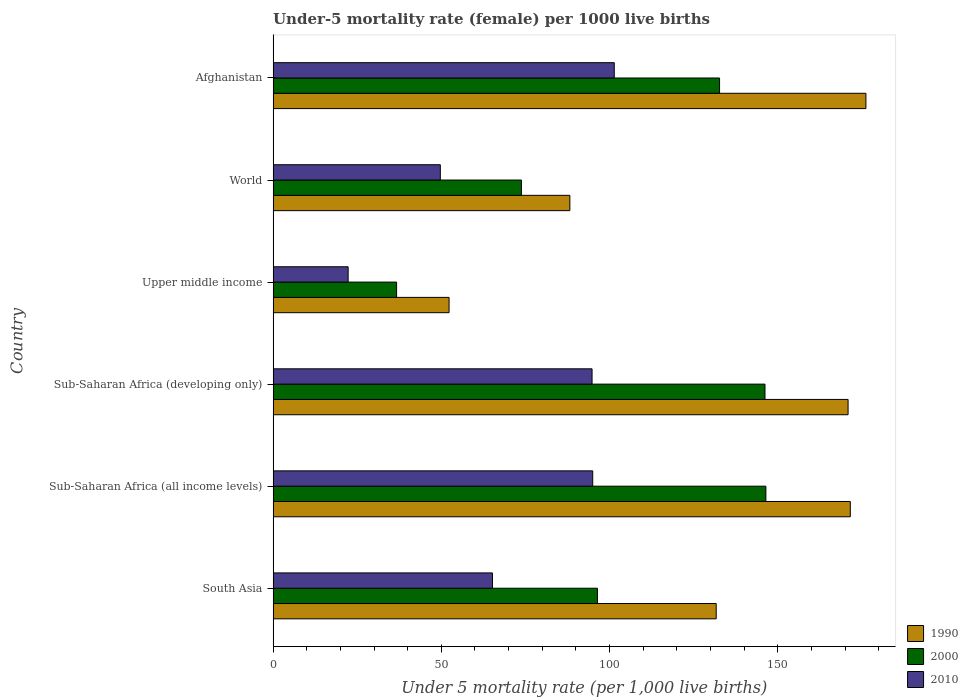Are the number of bars per tick equal to the number of legend labels?
Provide a short and direct response. Yes. How many bars are there on the 1st tick from the top?
Ensure brevity in your answer.  3. How many bars are there on the 2nd tick from the bottom?
Your response must be concise. 3. In how many cases, is the number of bars for a given country not equal to the number of legend labels?
Provide a short and direct response. 0. What is the under-five mortality rate in 1990 in South Asia?
Ensure brevity in your answer.  131.7. Across all countries, what is the maximum under-five mortality rate in 1990?
Make the answer very short. 176.2. Across all countries, what is the minimum under-five mortality rate in 2000?
Your answer should be very brief. 36.7. In which country was the under-five mortality rate in 2000 maximum?
Keep it short and to the point. Sub-Saharan Africa (all income levels). In which country was the under-five mortality rate in 1990 minimum?
Provide a short and direct response. Upper middle income. What is the total under-five mortality rate in 1990 in the graph?
Keep it short and to the point. 790.86. What is the difference between the under-five mortality rate in 1990 in Afghanistan and that in Upper middle income?
Offer a terse response. 123.9. What is the average under-five mortality rate in 2010 per country?
Your response must be concise. 71.4. What is the difference between the under-five mortality rate in 1990 and under-five mortality rate in 2000 in Sub-Saharan Africa (developing only)?
Your answer should be very brief. 24.7. In how many countries, is the under-five mortality rate in 1990 greater than 130 ?
Make the answer very short. 4. What is the ratio of the under-five mortality rate in 2010 in Afghanistan to that in Sub-Saharan Africa (all income levels)?
Provide a succinct answer. 1.07. What is the difference between the highest and the second highest under-five mortality rate in 1990?
Give a very brief answer. 4.64. What is the difference between the highest and the lowest under-five mortality rate in 1990?
Your answer should be compact. 123.9. In how many countries, is the under-five mortality rate in 2010 greater than the average under-five mortality rate in 2010 taken over all countries?
Your answer should be compact. 3. Is the sum of the under-five mortality rate in 1990 in Afghanistan and South Asia greater than the maximum under-five mortality rate in 2010 across all countries?
Provide a succinct answer. Yes. What does the 1st bar from the top in Sub-Saharan Africa (all income levels) represents?
Your answer should be compact. 2010. What does the 1st bar from the bottom in Afghanistan represents?
Your answer should be very brief. 1990. Is it the case that in every country, the sum of the under-five mortality rate in 1990 and under-five mortality rate in 2000 is greater than the under-five mortality rate in 2010?
Offer a very short reply. Yes. How many bars are there?
Keep it short and to the point. 18. How many countries are there in the graph?
Offer a very short reply. 6. What is the difference between two consecutive major ticks on the X-axis?
Make the answer very short. 50. Are the values on the major ticks of X-axis written in scientific E-notation?
Provide a short and direct response. No. Does the graph contain any zero values?
Offer a terse response. No. How are the legend labels stacked?
Your answer should be very brief. Vertical. What is the title of the graph?
Your answer should be very brief. Under-5 mortality rate (female) per 1000 live births. Does "1972" appear as one of the legend labels in the graph?
Provide a succinct answer. No. What is the label or title of the X-axis?
Offer a very short reply. Under 5 mortality rate (per 1,0 live births). What is the label or title of the Y-axis?
Offer a terse response. Country. What is the Under 5 mortality rate (per 1,000 live births) in 1990 in South Asia?
Your answer should be compact. 131.7. What is the Under 5 mortality rate (per 1,000 live births) in 2000 in South Asia?
Offer a terse response. 96.4. What is the Under 5 mortality rate (per 1,000 live births) in 2010 in South Asia?
Your response must be concise. 65.2. What is the Under 5 mortality rate (per 1,000 live births) in 1990 in Sub-Saharan Africa (all income levels)?
Ensure brevity in your answer.  171.56. What is the Under 5 mortality rate (per 1,000 live births) in 2000 in Sub-Saharan Africa (all income levels)?
Give a very brief answer. 146.47. What is the Under 5 mortality rate (per 1,000 live births) in 2010 in Sub-Saharan Africa (all income levels)?
Offer a very short reply. 95. What is the Under 5 mortality rate (per 1,000 live births) in 1990 in Sub-Saharan Africa (developing only)?
Your response must be concise. 170.9. What is the Under 5 mortality rate (per 1,000 live births) of 2000 in Sub-Saharan Africa (developing only)?
Your answer should be very brief. 146.2. What is the Under 5 mortality rate (per 1,000 live births) of 2010 in Sub-Saharan Africa (developing only)?
Ensure brevity in your answer.  94.8. What is the Under 5 mortality rate (per 1,000 live births) of 1990 in Upper middle income?
Provide a short and direct response. 52.3. What is the Under 5 mortality rate (per 1,000 live births) in 2000 in Upper middle income?
Make the answer very short. 36.7. What is the Under 5 mortality rate (per 1,000 live births) of 2010 in Upper middle income?
Provide a succinct answer. 22.3. What is the Under 5 mortality rate (per 1,000 live births) of 1990 in World?
Provide a succinct answer. 88.2. What is the Under 5 mortality rate (per 1,000 live births) of 2000 in World?
Give a very brief answer. 73.8. What is the Under 5 mortality rate (per 1,000 live births) in 2010 in World?
Provide a short and direct response. 49.7. What is the Under 5 mortality rate (per 1,000 live births) of 1990 in Afghanistan?
Make the answer very short. 176.2. What is the Under 5 mortality rate (per 1,000 live births) of 2000 in Afghanistan?
Make the answer very short. 132.7. What is the Under 5 mortality rate (per 1,000 live births) of 2010 in Afghanistan?
Your response must be concise. 101.4. Across all countries, what is the maximum Under 5 mortality rate (per 1,000 live births) of 1990?
Your answer should be very brief. 176.2. Across all countries, what is the maximum Under 5 mortality rate (per 1,000 live births) in 2000?
Ensure brevity in your answer.  146.47. Across all countries, what is the maximum Under 5 mortality rate (per 1,000 live births) of 2010?
Provide a succinct answer. 101.4. Across all countries, what is the minimum Under 5 mortality rate (per 1,000 live births) of 1990?
Your response must be concise. 52.3. Across all countries, what is the minimum Under 5 mortality rate (per 1,000 live births) of 2000?
Ensure brevity in your answer.  36.7. Across all countries, what is the minimum Under 5 mortality rate (per 1,000 live births) of 2010?
Keep it short and to the point. 22.3. What is the total Under 5 mortality rate (per 1,000 live births) in 1990 in the graph?
Give a very brief answer. 790.86. What is the total Under 5 mortality rate (per 1,000 live births) in 2000 in the graph?
Offer a very short reply. 632.26. What is the total Under 5 mortality rate (per 1,000 live births) of 2010 in the graph?
Provide a succinct answer. 428.4. What is the difference between the Under 5 mortality rate (per 1,000 live births) of 1990 in South Asia and that in Sub-Saharan Africa (all income levels)?
Your answer should be compact. -39.86. What is the difference between the Under 5 mortality rate (per 1,000 live births) of 2000 in South Asia and that in Sub-Saharan Africa (all income levels)?
Give a very brief answer. -50.06. What is the difference between the Under 5 mortality rate (per 1,000 live births) in 2010 in South Asia and that in Sub-Saharan Africa (all income levels)?
Make the answer very short. -29.8. What is the difference between the Under 5 mortality rate (per 1,000 live births) of 1990 in South Asia and that in Sub-Saharan Africa (developing only)?
Your answer should be compact. -39.2. What is the difference between the Under 5 mortality rate (per 1,000 live births) of 2000 in South Asia and that in Sub-Saharan Africa (developing only)?
Provide a succinct answer. -49.8. What is the difference between the Under 5 mortality rate (per 1,000 live births) of 2010 in South Asia and that in Sub-Saharan Africa (developing only)?
Your response must be concise. -29.6. What is the difference between the Under 5 mortality rate (per 1,000 live births) of 1990 in South Asia and that in Upper middle income?
Your response must be concise. 79.4. What is the difference between the Under 5 mortality rate (per 1,000 live births) of 2000 in South Asia and that in Upper middle income?
Offer a terse response. 59.7. What is the difference between the Under 5 mortality rate (per 1,000 live births) in 2010 in South Asia and that in Upper middle income?
Ensure brevity in your answer.  42.9. What is the difference between the Under 5 mortality rate (per 1,000 live births) of 1990 in South Asia and that in World?
Provide a succinct answer. 43.5. What is the difference between the Under 5 mortality rate (per 1,000 live births) of 2000 in South Asia and that in World?
Your answer should be compact. 22.6. What is the difference between the Under 5 mortality rate (per 1,000 live births) of 1990 in South Asia and that in Afghanistan?
Your answer should be very brief. -44.5. What is the difference between the Under 5 mortality rate (per 1,000 live births) in 2000 in South Asia and that in Afghanistan?
Provide a succinct answer. -36.3. What is the difference between the Under 5 mortality rate (per 1,000 live births) in 2010 in South Asia and that in Afghanistan?
Provide a short and direct response. -36.2. What is the difference between the Under 5 mortality rate (per 1,000 live births) of 1990 in Sub-Saharan Africa (all income levels) and that in Sub-Saharan Africa (developing only)?
Make the answer very short. 0.66. What is the difference between the Under 5 mortality rate (per 1,000 live births) in 2000 in Sub-Saharan Africa (all income levels) and that in Sub-Saharan Africa (developing only)?
Make the answer very short. 0.27. What is the difference between the Under 5 mortality rate (per 1,000 live births) in 2010 in Sub-Saharan Africa (all income levels) and that in Sub-Saharan Africa (developing only)?
Offer a terse response. 0.2. What is the difference between the Under 5 mortality rate (per 1,000 live births) in 1990 in Sub-Saharan Africa (all income levels) and that in Upper middle income?
Provide a succinct answer. 119.26. What is the difference between the Under 5 mortality rate (per 1,000 live births) in 2000 in Sub-Saharan Africa (all income levels) and that in Upper middle income?
Provide a short and direct response. 109.77. What is the difference between the Under 5 mortality rate (per 1,000 live births) of 2010 in Sub-Saharan Africa (all income levels) and that in Upper middle income?
Your answer should be compact. 72.7. What is the difference between the Under 5 mortality rate (per 1,000 live births) of 1990 in Sub-Saharan Africa (all income levels) and that in World?
Your answer should be compact. 83.36. What is the difference between the Under 5 mortality rate (per 1,000 live births) of 2000 in Sub-Saharan Africa (all income levels) and that in World?
Provide a succinct answer. 72.67. What is the difference between the Under 5 mortality rate (per 1,000 live births) of 2010 in Sub-Saharan Africa (all income levels) and that in World?
Provide a succinct answer. 45.3. What is the difference between the Under 5 mortality rate (per 1,000 live births) of 1990 in Sub-Saharan Africa (all income levels) and that in Afghanistan?
Offer a terse response. -4.64. What is the difference between the Under 5 mortality rate (per 1,000 live births) in 2000 in Sub-Saharan Africa (all income levels) and that in Afghanistan?
Ensure brevity in your answer.  13.77. What is the difference between the Under 5 mortality rate (per 1,000 live births) in 2010 in Sub-Saharan Africa (all income levels) and that in Afghanistan?
Make the answer very short. -6.4. What is the difference between the Under 5 mortality rate (per 1,000 live births) in 1990 in Sub-Saharan Africa (developing only) and that in Upper middle income?
Your answer should be compact. 118.6. What is the difference between the Under 5 mortality rate (per 1,000 live births) in 2000 in Sub-Saharan Africa (developing only) and that in Upper middle income?
Offer a terse response. 109.5. What is the difference between the Under 5 mortality rate (per 1,000 live births) of 2010 in Sub-Saharan Africa (developing only) and that in Upper middle income?
Your response must be concise. 72.5. What is the difference between the Under 5 mortality rate (per 1,000 live births) of 1990 in Sub-Saharan Africa (developing only) and that in World?
Your answer should be very brief. 82.7. What is the difference between the Under 5 mortality rate (per 1,000 live births) in 2000 in Sub-Saharan Africa (developing only) and that in World?
Give a very brief answer. 72.4. What is the difference between the Under 5 mortality rate (per 1,000 live births) in 2010 in Sub-Saharan Africa (developing only) and that in World?
Your response must be concise. 45.1. What is the difference between the Under 5 mortality rate (per 1,000 live births) in 1990 in Sub-Saharan Africa (developing only) and that in Afghanistan?
Make the answer very short. -5.3. What is the difference between the Under 5 mortality rate (per 1,000 live births) in 2010 in Sub-Saharan Africa (developing only) and that in Afghanistan?
Make the answer very short. -6.6. What is the difference between the Under 5 mortality rate (per 1,000 live births) in 1990 in Upper middle income and that in World?
Provide a succinct answer. -35.9. What is the difference between the Under 5 mortality rate (per 1,000 live births) of 2000 in Upper middle income and that in World?
Ensure brevity in your answer.  -37.1. What is the difference between the Under 5 mortality rate (per 1,000 live births) in 2010 in Upper middle income and that in World?
Ensure brevity in your answer.  -27.4. What is the difference between the Under 5 mortality rate (per 1,000 live births) in 1990 in Upper middle income and that in Afghanistan?
Keep it short and to the point. -123.9. What is the difference between the Under 5 mortality rate (per 1,000 live births) in 2000 in Upper middle income and that in Afghanistan?
Keep it short and to the point. -96. What is the difference between the Under 5 mortality rate (per 1,000 live births) of 2010 in Upper middle income and that in Afghanistan?
Ensure brevity in your answer.  -79.1. What is the difference between the Under 5 mortality rate (per 1,000 live births) in 1990 in World and that in Afghanistan?
Your answer should be compact. -88. What is the difference between the Under 5 mortality rate (per 1,000 live births) in 2000 in World and that in Afghanistan?
Provide a short and direct response. -58.9. What is the difference between the Under 5 mortality rate (per 1,000 live births) in 2010 in World and that in Afghanistan?
Your answer should be very brief. -51.7. What is the difference between the Under 5 mortality rate (per 1,000 live births) in 1990 in South Asia and the Under 5 mortality rate (per 1,000 live births) in 2000 in Sub-Saharan Africa (all income levels)?
Keep it short and to the point. -14.77. What is the difference between the Under 5 mortality rate (per 1,000 live births) in 1990 in South Asia and the Under 5 mortality rate (per 1,000 live births) in 2010 in Sub-Saharan Africa (all income levels)?
Offer a terse response. 36.7. What is the difference between the Under 5 mortality rate (per 1,000 live births) of 2000 in South Asia and the Under 5 mortality rate (per 1,000 live births) of 2010 in Sub-Saharan Africa (all income levels)?
Your response must be concise. 1.4. What is the difference between the Under 5 mortality rate (per 1,000 live births) in 1990 in South Asia and the Under 5 mortality rate (per 1,000 live births) in 2010 in Sub-Saharan Africa (developing only)?
Offer a very short reply. 36.9. What is the difference between the Under 5 mortality rate (per 1,000 live births) in 2000 in South Asia and the Under 5 mortality rate (per 1,000 live births) in 2010 in Sub-Saharan Africa (developing only)?
Offer a very short reply. 1.6. What is the difference between the Under 5 mortality rate (per 1,000 live births) in 1990 in South Asia and the Under 5 mortality rate (per 1,000 live births) in 2000 in Upper middle income?
Offer a very short reply. 95. What is the difference between the Under 5 mortality rate (per 1,000 live births) in 1990 in South Asia and the Under 5 mortality rate (per 1,000 live births) in 2010 in Upper middle income?
Offer a very short reply. 109.4. What is the difference between the Under 5 mortality rate (per 1,000 live births) in 2000 in South Asia and the Under 5 mortality rate (per 1,000 live births) in 2010 in Upper middle income?
Make the answer very short. 74.1. What is the difference between the Under 5 mortality rate (per 1,000 live births) of 1990 in South Asia and the Under 5 mortality rate (per 1,000 live births) of 2000 in World?
Provide a succinct answer. 57.9. What is the difference between the Under 5 mortality rate (per 1,000 live births) in 1990 in South Asia and the Under 5 mortality rate (per 1,000 live births) in 2010 in World?
Your answer should be compact. 82. What is the difference between the Under 5 mortality rate (per 1,000 live births) in 2000 in South Asia and the Under 5 mortality rate (per 1,000 live births) in 2010 in World?
Your response must be concise. 46.7. What is the difference between the Under 5 mortality rate (per 1,000 live births) in 1990 in South Asia and the Under 5 mortality rate (per 1,000 live births) in 2010 in Afghanistan?
Provide a succinct answer. 30.3. What is the difference between the Under 5 mortality rate (per 1,000 live births) in 1990 in Sub-Saharan Africa (all income levels) and the Under 5 mortality rate (per 1,000 live births) in 2000 in Sub-Saharan Africa (developing only)?
Provide a short and direct response. 25.36. What is the difference between the Under 5 mortality rate (per 1,000 live births) of 1990 in Sub-Saharan Africa (all income levels) and the Under 5 mortality rate (per 1,000 live births) of 2010 in Sub-Saharan Africa (developing only)?
Offer a very short reply. 76.76. What is the difference between the Under 5 mortality rate (per 1,000 live births) in 2000 in Sub-Saharan Africa (all income levels) and the Under 5 mortality rate (per 1,000 live births) in 2010 in Sub-Saharan Africa (developing only)?
Offer a terse response. 51.66. What is the difference between the Under 5 mortality rate (per 1,000 live births) in 1990 in Sub-Saharan Africa (all income levels) and the Under 5 mortality rate (per 1,000 live births) in 2000 in Upper middle income?
Give a very brief answer. 134.86. What is the difference between the Under 5 mortality rate (per 1,000 live births) in 1990 in Sub-Saharan Africa (all income levels) and the Under 5 mortality rate (per 1,000 live births) in 2010 in Upper middle income?
Ensure brevity in your answer.  149.26. What is the difference between the Under 5 mortality rate (per 1,000 live births) in 2000 in Sub-Saharan Africa (all income levels) and the Under 5 mortality rate (per 1,000 live births) in 2010 in Upper middle income?
Offer a terse response. 124.17. What is the difference between the Under 5 mortality rate (per 1,000 live births) in 1990 in Sub-Saharan Africa (all income levels) and the Under 5 mortality rate (per 1,000 live births) in 2000 in World?
Offer a terse response. 97.76. What is the difference between the Under 5 mortality rate (per 1,000 live births) in 1990 in Sub-Saharan Africa (all income levels) and the Under 5 mortality rate (per 1,000 live births) in 2010 in World?
Offer a very short reply. 121.86. What is the difference between the Under 5 mortality rate (per 1,000 live births) in 2000 in Sub-Saharan Africa (all income levels) and the Under 5 mortality rate (per 1,000 live births) in 2010 in World?
Keep it short and to the point. 96.77. What is the difference between the Under 5 mortality rate (per 1,000 live births) in 1990 in Sub-Saharan Africa (all income levels) and the Under 5 mortality rate (per 1,000 live births) in 2000 in Afghanistan?
Make the answer very short. 38.86. What is the difference between the Under 5 mortality rate (per 1,000 live births) of 1990 in Sub-Saharan Africa (all income levels) and the Under 5 mortality rate (per 1,000 live births) of 2010 in Afghanistan?
Offer a very short reply. 70.16. What is the difference between the Under 5 mortality rate (per 1,000 live births) in 2000 in Sub-Saharan Africa (all income levels) and the Under 5 mortality rate (per 1,000 live births) in 2010 in Afghanistan?
Provide a short and direct response. 45.06. What is the difference between the Under 5 mortality rate (per 1,000 live births) of 1990 in Sub-Saharan Africa (developing only) and the Under 5 mortality rate (per 1,000 live births) of 2000 in Upper middle income?
Offer a very short reply. 134.2. What is the difference between the Under 5 mortality rate (per 1,000 live births) of 1990 in Sub-Saharan Africa (developing only) and the Under 5 mortality rate (per 1,000 live births) of 2010 in Upper middle income?
Ensure brevity in your answer.  148.6. What is the difference between the Under 5 mortality rate (per 1,000 live births) of 2000 in Sub-Saharan Africa (developing only) and the Under 5 mortality rate (per 1,000 live births) of 2010 in Upper middle income?
Your answer should be compact. 123.9. What is the difference between the Under 5 mortality rate (per 1,000 live births) of 1990 in Sub-Saharan Africa (developing only) and the Under 5 mortality rate (per 1,000 live births) of 2000 in World?
Offer a very short reply. 97.1. What is the difference between the Under 5 mortality rate (per 1,000 live births) of 1990 in Sub-Saharan Africa (developing only) and the Under 5 mortality rate (per 1,000 live births) of 2010 in World?
Provide a succinct answer. 121.2. What is the difference between the Under 5 mortality rate (per 1,000 live births) of 2000 in Sub-Saharan Africa (developing only) and the Under 5 mortality rate (per 1,000 live births) of 2010 in World?
Your answer should be very brief. 96.5. What is the difference between the Under 5 mortality rate (per 1,000 live births) in 1990 in Sub-Saharan Africa (developing only) and the Under 5 mortality rate (per 1,000 live births) in 2000 in Afghanistan?
Give a very brief answer. 38.2. What is the difference between the Under 5 mortality rate (per 1,000 live births) in 1990 in Sub-Saharan Africa (developing only) and the Under 5 mortality rate (per 1,000 live births) in 2010 in Afghanistan?
Give a very brief answer. 69.5. What is the difference between the Under 5 mortality rate (per 1,000 live births) in 2000 in Sub-Saharan Africa (developing only) and the Under 5 mortality rate (per 1,000 live births) in 2010 in Afghanistan?
Provide a short and direct response. 44.8. What is the difference between the Under 5 mortality rate (per 1,000 live births) in 1990 in Upper middle income and the Under 5 mortality rate (per 1,000 live births) in 2000 in World?
Give a very brief answer. -21.5. What is the difference between the Under 5 mortality rate (per 1,000 live births) in 2000 in Upper middle income and the Under 5 mortality rate (per 1,000 live births) in 2010 in World?
Give a very brief answer. -13. What is the difference between the Under 5 mortality rate (per 1,000 live births) of 1990 in Upper middle income and the Under 5 mortality rate (per 1,000 live births) of 2000 in Afghanistan?
Ensure brevity in your answer.  -80.4. What is the difference between the Under 5 mortality rate (per 1,000 live births) of 1990 in Upper middle income and the Under 5 mortality rate (per 1,000 live births) of 2010 in Afghanistan?
Your answer should be compact. -49.1. What is the difference between the Under 5 mortality rate (per 1,000 live births) in 2000 in Upper middle income and the Under 5 mortality rate (per 1,000 live births) in 2010 in Afghanistan?
Your answer should be very brief. -64.7. What is the difference between the Under 5 mortality rate (per 1,000 live births) in 1990 in World and the Under 5 mortality rate (per 1,000 live births) in 2000 in Afghanistan?
Offer a very short reply. -44.5. What is the difference between the Under 5 mortality rate (per 1,000 live births) of 1990 in World and the Under 5 mortality rate (per 1,000 live births) of 2010 in Afghanistan?
Your answer should be very brief. -13.2. What is the difference between the Under 5 mortality rate (per 1,000 live births) of 2000 in World and the Under 5 mortality rate (per 1,000 live births) of 2010 in Afghanistan?
Your response must be concise. -27.6. What is the average Under 5 mortality rate (per 1,000 live births) in 1990 per country?
Your answer should be compact. 131.81. What is the average Under 5 mortality rate (per 1,000 live births) of 2000 per country?
Provide a short and direct response. 105.38. What is the average Under 5 mortality rate (per 1,000 live births) of 2010 per country?
Give a very brief answer. 71.4. What is the difference between the Under 5 mortality rate (per 1,000 live births) of 1990 and Under 5 mortality rate (per 1,000 live births) of 2000 in South Asia?
Keep it short and to the point. 35.3. What is the difference between the Under 5 mortality rate (per 1,000 live births) in 1990 and Under 5 mortality rate (per 1,000 live births) in 2010 in South Asia?
Keep it short and to the point. 66.5. What is the difference between the Under 5 mortality rate (per 1,000 live births) in 2000 and Under 5 mortality rate (per 1,000 live births) in 2010 in South Asia?
Offer a very short reply. 31.2. What is the difference between the Under 5 mortality rate (per 1,000 live births) of 1990 and Under 5 mortality rate (per 1,000 live births) of 2000 in Sub-Saharan Africa (all income levels)?
Give a very brief answer. 25.09. What is the difference between the Under 5 mortality rate (per 1,000 live births) in 1990 and Under 5 mortality rate (per 1,000 live births) in 2010 in Sub-Saharan Africa (all income levels)?
Provide a short and direct response. 76.56. What is the difference between the Under 5 mortality rate (per 1,000 live births) of 2000 and Under 5 mortality rate (per 1,000 live births) of 2010 in Sub-Saharan Africa (all income levels)?
Keep it short and to the point. 51.47. What is the difference between the Under 5 mortality rate (per 1,000 live births) in 1990 and Under 5 mortality rate (per 1,000 live births) in 2000 in Sub-Saharan Africa (developing only)?
Offer a terse response. 24.7. What is the difference between the Under 5 mortality rate (per 1,000 live births) in 1990 and Under 5 mortality rate (per 1,000 live births) in 2010 in Sub-Saharan Africa (developing only)?
Your answer should be compact. 76.1. What is the difference between the Under 5 mortality rate (per 1,000 live births) in 2000 and Under 5 mortality rate (per 1,000 live births) in 2010 in Sub-Saharan Africa (developing only)?
Your answer should be compact. 51.4. What is the difference between the Under 5 mortality rate (per 1,000 live births) in 1990 and Under 5 mortality rate (per 1,000 live births) in 2000 in Upper middle income?
Your answer should be very brief. 15.6. What is the difference between the Under 5 mortality rate (per 1,000 live births) of 1990 and Under 5 mortality rate (per 1,000 live births) of 2010 in Upper middle income?
Offer a terse response. 30. What is the difference between the Under 5 mortality rate (per 1,000 live births) of 2000 and Under 5 mortality rate (per 1,000 live births) of 2010 in Upper middle income?
Give a very brief answer. 14.4. What is the difference between the Under 5 mortality rate (per 1,000 live births) in 1990 and Under 5 mortality rate (per 1,000 live births) in 2000 in World?
Your answer should be very brief. 14.4. What is the difference between the Under 5 mortality rate (per 1,000 live births) in 1990 and Under 5 mortality rate (per 1,000 live births) in 2010 in World?
Ensure brevity in your answer.  38.5. What is the difference between the Under 5 mortality rate (per 1,000 live births) in 2000 and Under 5 mortality rate (per 1,000 live births) in 2010 in World?
Your answer should be very brief. 24.1. What is the difference between the Under 5 mortality rate (per 1,000 live births) in 1990 and Under 5 mortality rate (per 1,000 live births) in 2000 in Afghanistan?
Offer a very short reply. 43.5. What is the difference between the Under 5 mortality rate (per 1,000 live births) of 1990 and Under 5 mortality rate (per 1,000 live births) of 2010 in Afghanistan?
Your answer should be compact. 74.8. What is the difference between the Under 5 mortality rate (per 1,000 live births) in 2000 and Under 5 mortality rate (per 1,000 live births) in 2010 in Afghanistan?
Offer a terse response. 31.3. What is the ratio of the Under 5 mortality rate (per 1,000 live births) of 1990 in South Asia to that in Sub-Saharan Africa (all income levels)?
Your response must be concise. 0.77. What is the ratio of the Under 5 mortality rate (per 1,000 live births) of 2000 in South Asia to that in Sub-Saharan Africa (all income levels)?
Make the answer very short. 0.66. What is the ratio of the Under 5 mortality rate (per 1,000 live births) in 2010 in South Asia to that in Sub-Saharan Africa (all income levels)?
Keep it short and to the point. 0.69. What is the ratio of the Under 5 mortality rate (per 1,000 live births) in 1990 in South Asia to that in Sub-Saharan Africa (developing only)?
Ensure brevity in your answer.  0.77. What is the ratio of the Under 5 mortality rate (per 1,000 live births) in 2000 in South Asia to that in Sub-Saharan Africa (developing only)?
Ensure brevity in your answer.  0.66. What is the ratio of the Under 5 mortality rate (per 1,000 live births) of 2010 in South Asia to that in Sub-Saharan Africa (developing only)?
Your answer should be very brief. 0.69. What is the ratio of the Under 5 mortality rate (per 1,000 live births) in 1990 in South Asia to that in Upper middle income?
Your response must be concise. 2.52. What is the ratio of the Under 5 mortality rate (per 1,000 live births) in 2000 in South Asia to that in Upper middle income?
Your answer should be very brief. 2.63. What is the ratio of the Under 5 mortality rate (per 1,000 live births) of 2010 in South Asia to that in Upper middle income?
Provide a succinct answer. 2.92. What is the ratio of the Under 5 mortality rate (per 1,000 live births) of 1990 in South Asia to that in World?
Give a very brief answer. 1.49. What is the ratio of the Under 5 mortality rate (per 1,000 live births) of 2000 in South Asia to that in World?
Offer a very short reply. 1.31. What is the ratio of the Under 5 mortality rate (per 1,000 live births) of 2010 in South Asia to that in World?
Your answer should be compact. 1.31. What is the ratio of the Under 5 mortality rate (per 1,000 live births) of 1990 in South Asia to that in Afghanistan?
Give a very brief answer. 0.75. What is the ratio of the Under 5 mortality rate (per 1,000 live births) in 2000 in South Asia to that in Afghanistan?
Ensure brevity in your answer.  0.73. What is the ratio of the Under 5 mortality rate (per 1,000 live births) in 2010 in South Asia to that in Afghanistan?
Offer a very short reply. 0.64. What is the ratio of the Under 5 mortality rate (per 1,000 live births) in 2010 in Sub-Saharan Africa (all income levels) to that in Sub-Saharan Africa (developing only)?
Give a very brief answer. 1. What is the ratio of the Under 5 mortality rate (per 1,000 live births) of 1990 in Sub-Saharan Africa (all income levels) to that in Upper middle income?
Provide a short and direct response. 3.28. What is the ratio of the Under 5 mortality rate (per 1,000 live births) in 2000 in Sub-Saharan Africa (all income levels) to that in Upper middle income?
Provide a succinct answer. 3.99. What is the ratio of the Under 5 mortality rate (per 1,000 live births) of 2010 in Sub-Saharan Africa (all income levels) to that in Upper middle income?
Offer a terse response. 4.26. What is the ratio of the Under 5 mortality rate (per 1,000 live births) in 1990 in Sub-Saharan Africa (all income levels) to that in World?
Provide a succinct answer. 1.95. What is the ratio of the Under 5 mortality rate (per 1,000 live births) in 2000 in Sub-Saharan Africa (all income levels) to that in World?
Keep it short and to the point. 1.98. What is the ratio of the Under 5 mortality rate (per 1,000 live births) in 2010 in Sub-Saharan Africa (all income levels) to that in World?
Keep it short and to the point. 1.91. What is the ratio of the Under 5 mortality rate (per 1,000 live births) in 1990 in Sub-Saharan Africa (all income levels) to that in Afghanistan?
Provide a succinct answer. 0.97. What is the ratio of the Under 5 mortality rate (per 1,000 live births) in 2000 in Sub-Saharan Africa (all income levels) to that in Afghanistan?
Provide a succinct answer. 1.1. What is the ratio of the Under 5 mortality rate (per 1,000 live births) in 2010 in Sub-Saharan Africa (all income levels) to that in Afghanistan?
Ensure brevity in your answer.  0.94. What is the ratio of the Under 5 mortality rate (per 1,000 live births) in 1990 in Sub-Saharan Africa (developing only) to that in Upper middle income?
Ensure brevity in your answer.  3.27. What is the ratio of the Under 5 mortality rate (per 1,000 live births) in 2000 in Sub-Saharan Africa (developing only) to that in Upper middle income?
Provide a short and direct response. 3.98. What is the ratio of the Under 5 mortality rate (per 1,000 live births) of 2010 in Sub-Saharan Africa (developing only) to that in Upper middle income?
Provide a succinct answer. 4.25. What is the ratio of the Under 5 mortality rate (per 1,000 live births) of 1990 in Sub-Saharan Africa (developing only) to that in World?
Give a very brief answer. 1.94. What is the ratio of the Under 5 mortality rate (per 1,000 live births) in 2000 in Sub-Saharan Africa (developing only) to that in World?
Your answer should be compact. 1.98. What is the ratio of the Under 5 mortality rate (per 1,000 live births) in 2010 in Sub-Saharan Africa (developing only) to that in World?
Offer a terse response. 1.91. What is the ratio of the Under 5 mortality rate (per 1,000 live births) of 1990 in Sub-Saharan Africa (developing only) to that in Afghanistan?
Make the answer very short. 0.97. What is the ratio of the Under 5 mortality rate (per 1,000 live births) in 2000 in Sub-Saharan Africa (developing only) to that in Afghanistan?
Give a very brief answer. 1.1. What is the ratio of the Under 5 mortality rate (per 1,000 live births) of 2010 in Sub-Saharan Africa (developing only) to that in Afghanistan?
Your answer should be very brief. 0.93. What is the ratio of the Under 5 mortality rate (per 1,000 live births) of 1990 in Upper middle income to that in World?
Offer a terse response. 0.59. What is the ratio of the Under 5 mortality rate (per 1,000 live births) in 2000 in Upper middle income to that in World?
Keep it short and to the point. 0.5. What is the ratio of the Under 5 mortality rate (per 1,000 live births) in 2010 in Upper middle income to that in World?
Ensure brevity in your answer.  0.45. What is the ratio of the Under 5 mortality rate (per 1,000 live births) of 1990 in Upper middle income to that in Afghanistan?
Provide a succinct answer. 0.3. What is the ratio of the Under 5 mortality rate (per 1,000 live births) of 2000 in Upper middle income to that in Afghanistan?
Your response must be concise. 0.28. What is the ratio of the Under 5 mortality rate (per 1,000 live births) of 2010 in Upper middle income to that in Afghanistan?
Offer a terse response. 0.22. What is the ratio of the Under 5 mortality rate (per 1,000 live births) in 1990 in World to that in Afghanistan?
Your answer should be compact. 0.5. What is the ratio of the Under 5 mortality rate (per 1,000 live births) in 2000 in World to that in Afghanistan?
Make the answer very short. 0.56. What is the ratio of the Under 5 mortality rate (per 1,000 live births) of 2010 in World to that in Afghanistan?
Your response must be concise. 0.49. What is the difference between the highest and the second highest Under 5 mortality rate (per 1,000 live births) in 1990?
Your response must be concise. 4.64. What is the difference between the highest and the second highest Under 5 mortality rate (per 1,000 live births) of 2000?
Ensure brevity in your answer.  0.27. What is the difference between the highest and the second highest Under 5 mortality rate (per 1,000 live births) in 2010?
Your response must be concise. 6.4. What is the difference between the highest and the lowest Under 5 mortality rate (per 1,000 live births) in 1990?
Make the answer very short. 123.9. What is the difference between the highest and the lowest Under 5 mortality rate (per 1,000 live births) in 2000?
Provide a short and direct response. 109.77. What is the difference between the highest and the lowest Under 5 mortality rate (per 1,000 live births) of 2010?
Offer a terse response. 79.1. 